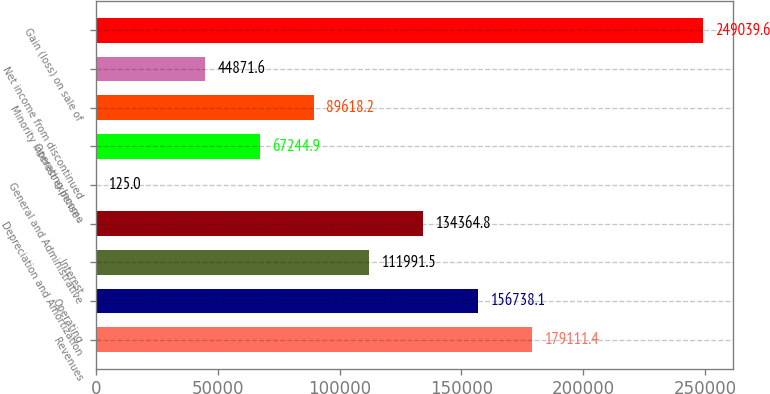Convert chart to OTSL. <chart><loc_0><loc_0><loc_500><loc_500><bar_chart><fcel>Revenues<fcel>Operating<fcel>Interest<fcel>Depreciation and Amortization<fcel>General and Administrative<fcel>Operating Income<fcel>Minority interest expense -<fcel>Net income from discontinued<fcel>Gain (loss) on sale of<nl><fcel>179111<fcel>156738<fcel>111992<fcel>134365<fcel>125<fcel>67244.9<fcel>89618.2<fcel>44871.6<fcel>249040<nl></chart> 